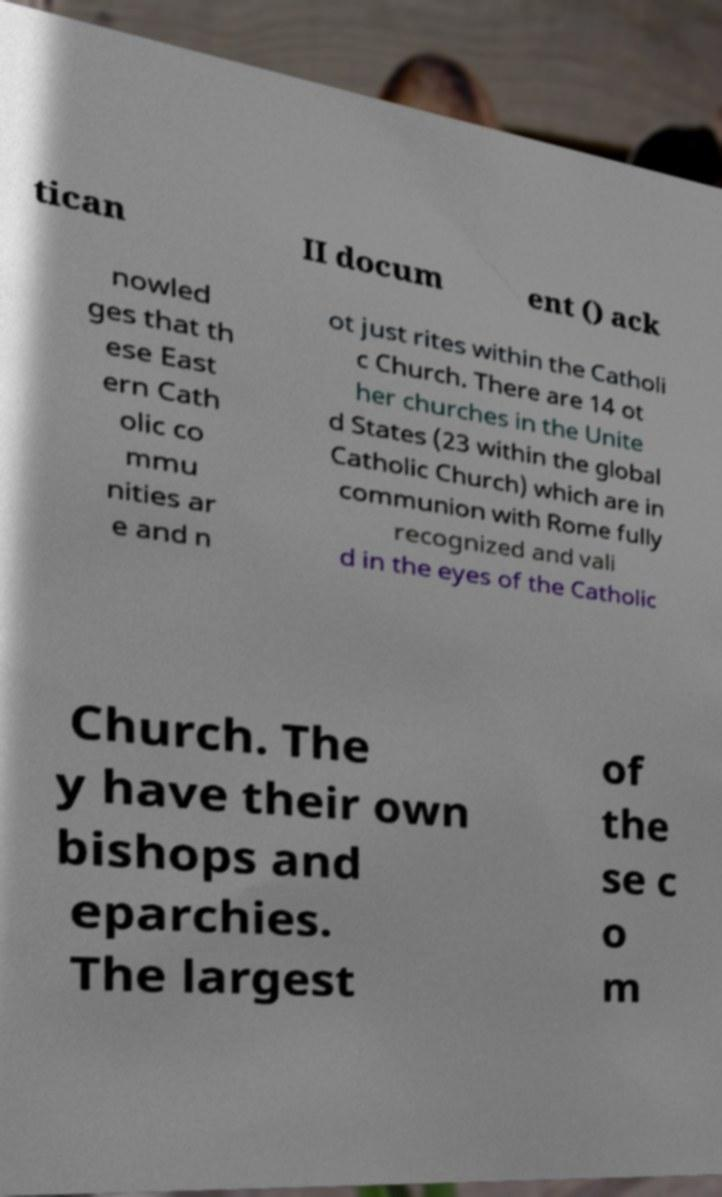I need the written content from this picture converted into text. Can you do that? tican II docum ent () ack nowled ges that th ese East ern Cath olic co mmu nities ar e and n ot just rites within the Catholi c Church. There are 14 ot her churches in the Unite d States (23 within the global Catholic Church) which are in communion with Rome fully recognized and vali d in the eyes of the Catholic Church. The y have their own bishops and eparchies. The largest of the se c o m 